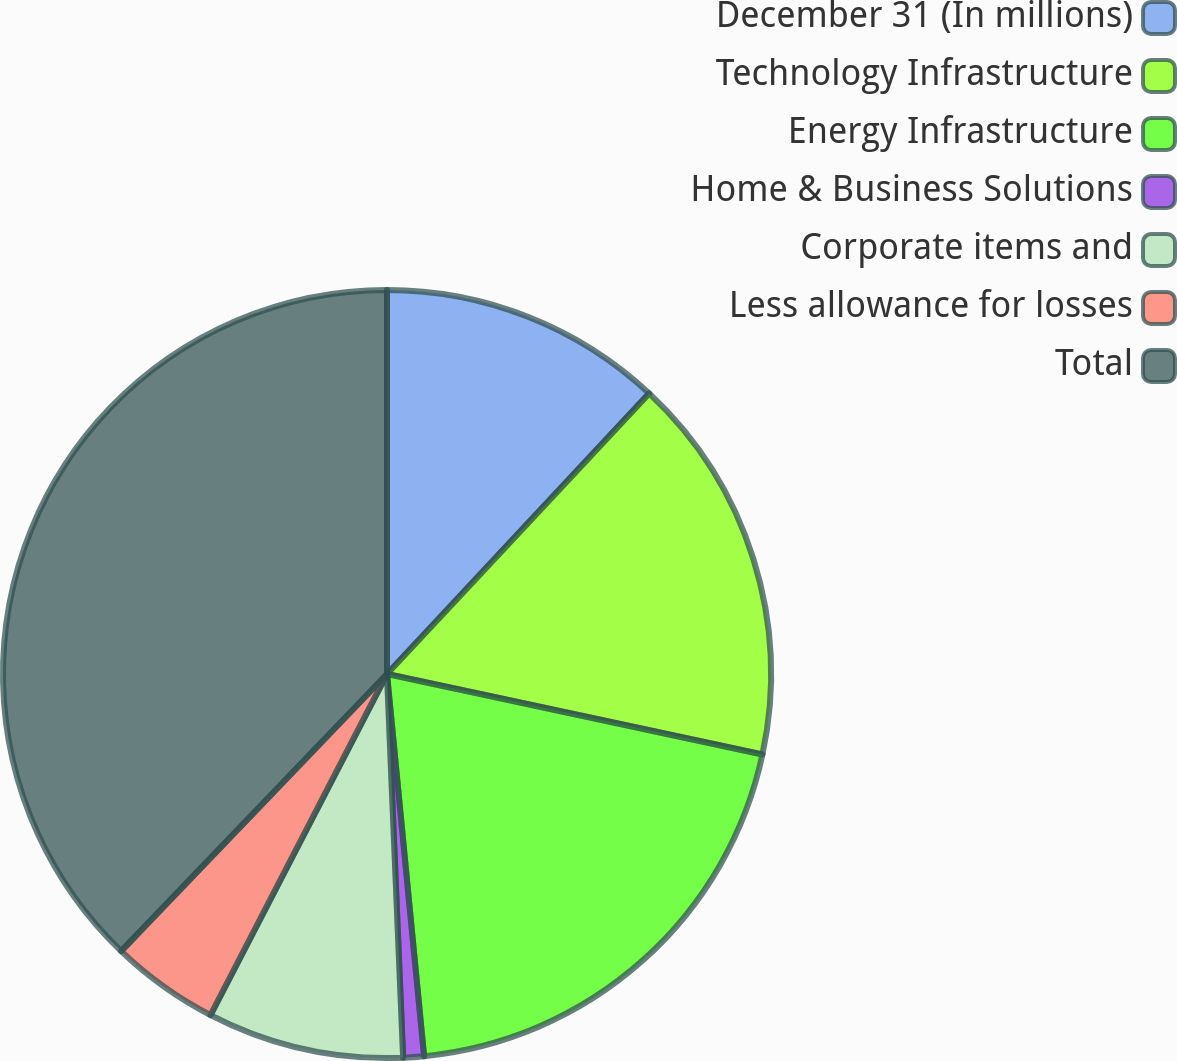Convert chart. <chart><loc_0><loc_0><loc_500><loc_500><pie_chart><fcel>December 31 (In millions)<fcel>Technology Infrastructure<fcel>Energy Infrastructure<fcel>Home & Business Solutions<fcel>Corporate items and<fcel>Less allowance for losses<fcel>Total<nl><fcel>11.96%<fcel>16.4%<fcel>20.1%<fcel>0.87%<fcel>8.27%<fcel>4.57%<fcel>37.83%<nl></chart> 